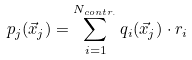Convert formula to latex. <formula><loc_0><loc_0><loc_500><loc_500>p _ { j } ( \vec { x } _ { j } ) = \sum _ { i = 1 } ^ { N _ { c o n t r . } } q { _ { i } } ( \vec { x } _ { j } ) \cdot r _ { i }</formula> 